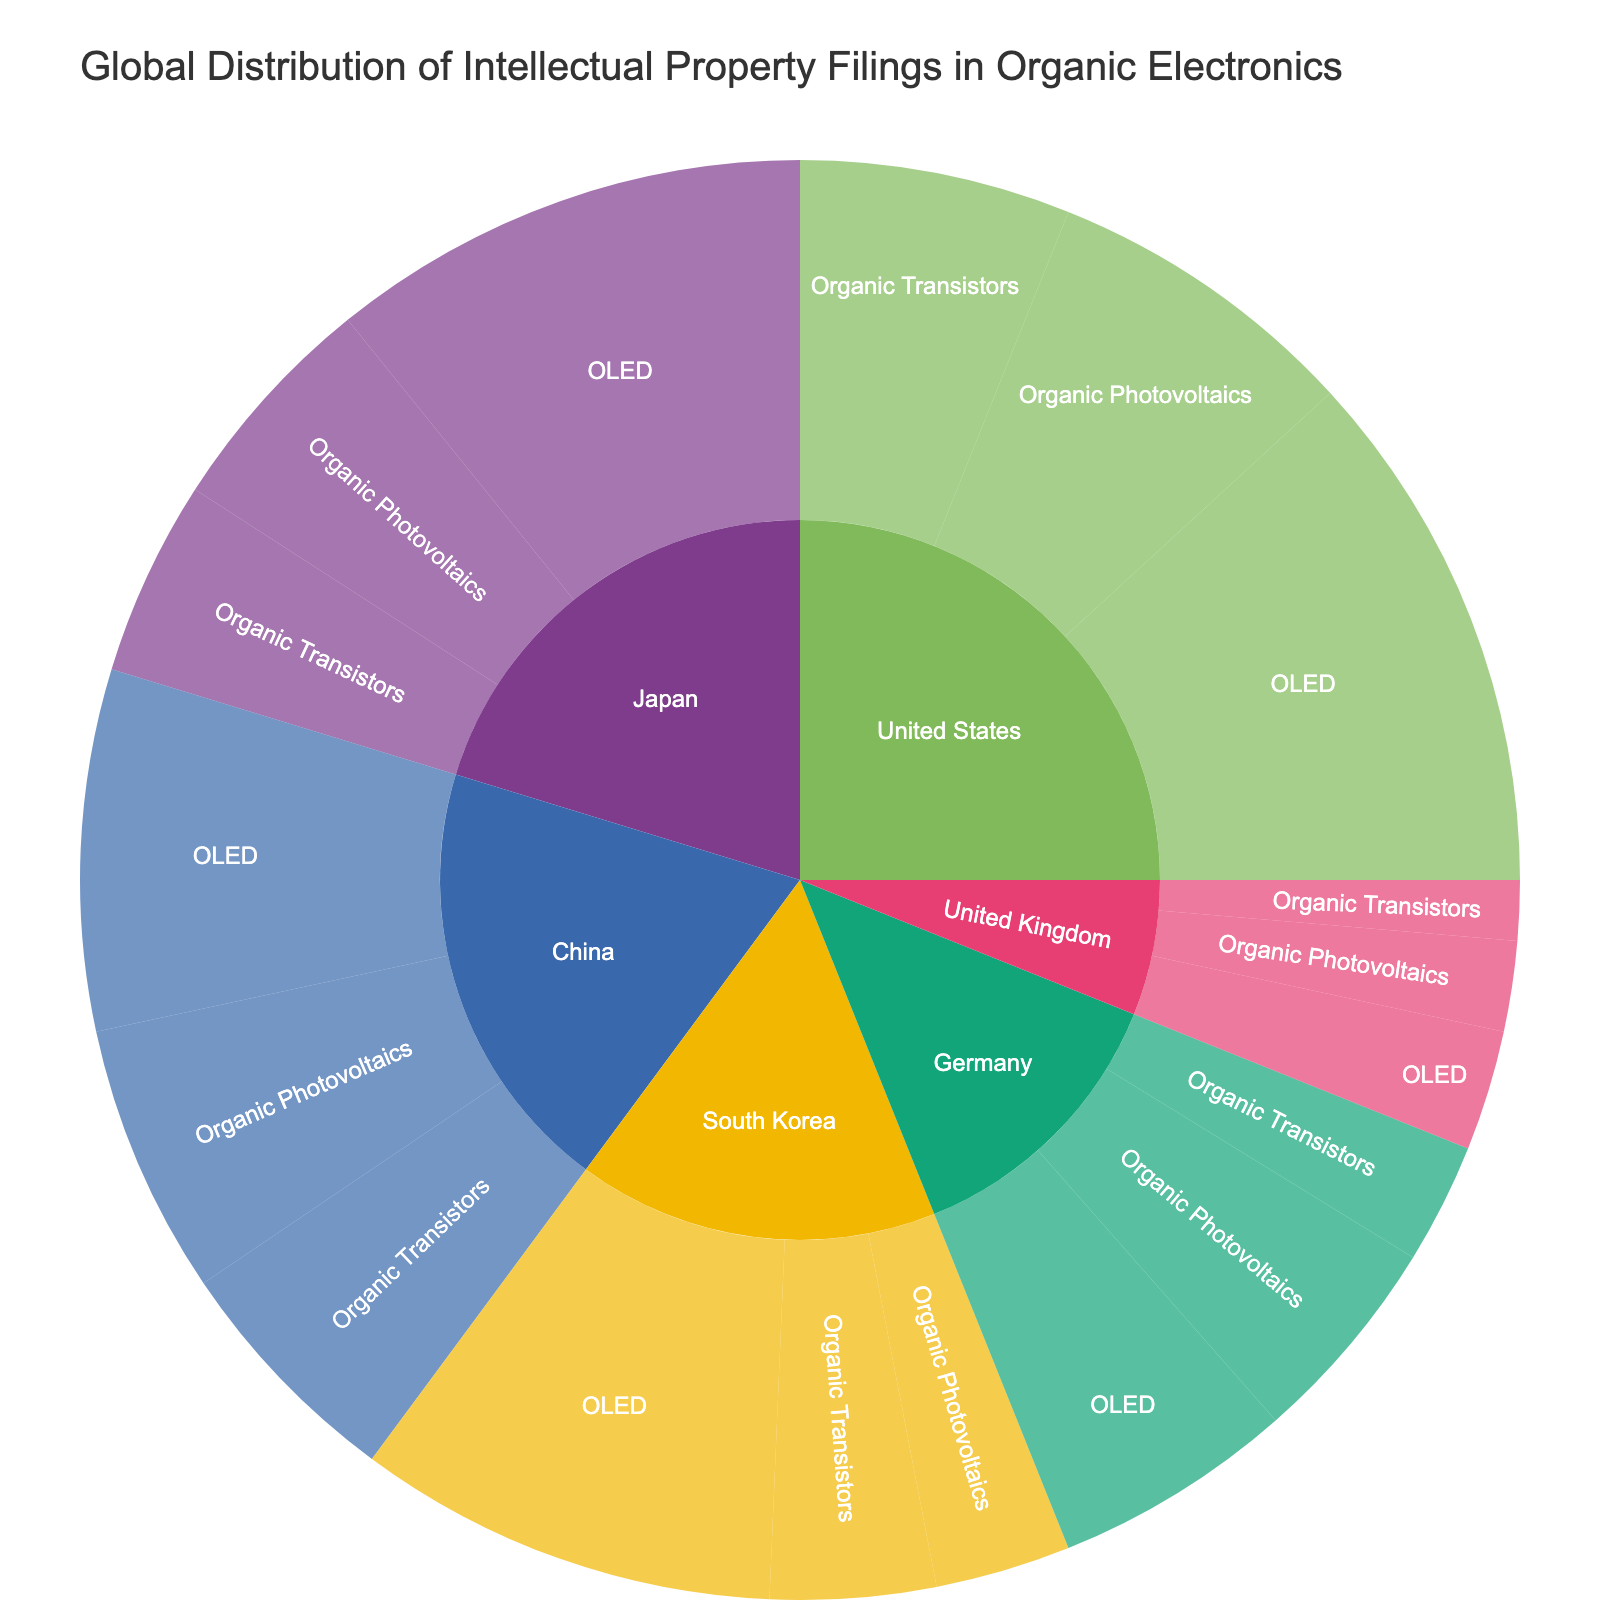How many patent filings are there for OLED technology in the United States? Locate the part of the sunburst plot showing the United States and then find the segment for OLED. Read off the number of filings.
Answer: 3500 Which country has the highest number of filings for Organic Photovoltaics? Examine the segments for all the countries and compare their respective filings for Organic Photovoltaics. The country with the highest number will be the answer.
Answer: United States What is the total number of filings for Organic Transistors across all countries? Sum the filings for Organic Transistors for each country: 1800 (US) + 1300 (Japan) + 1100 (South Korea) + 800 (Germany) + 1600 (China) + 400 (UK).
Answer: 7000 What is the difference in OLED filings between Japan and Germany? Find the OLED filings for Japan (3200) and Germany (1600) and subtract the latter from the former.
Answer: 1600 Which technology has the fewest filings in South Korea? Look at the filings for each technology in South Korea: OLED, Organic Photovoltaics, and Organic Transistors. Determine which one has the lowest number.
Answer: Organic Photovoltaics How does the total number of filings in China compare to Japan? Sum the filings of all technologies for China and Japan separately. Compare the totals.
Answer: China has more What is the average number of filings for Organic Photovoltaics across all the countries? Sum the filings for Organic Photovoltaics for all countries and divide by the number of countries: (2100+1500+900+1400+1800+600)/6.
Answer: 1383 What percentage of the total OLED filings worldwide come from South Korea? Calculate the total OLED filings worldwide by summing the OLED filings of all countries. Divide South Korea's OLED filings by this total and multiply by 100 to get the percentage: (2800 / (3500+3200+2800+1600+2400+800)) * 100.
Answer: 19.4% Which country has the smallest total number of patent filings for organic electronics? Add up the filings for each technology for each country and determine the smallest sum.
Answer: United Kingdom 